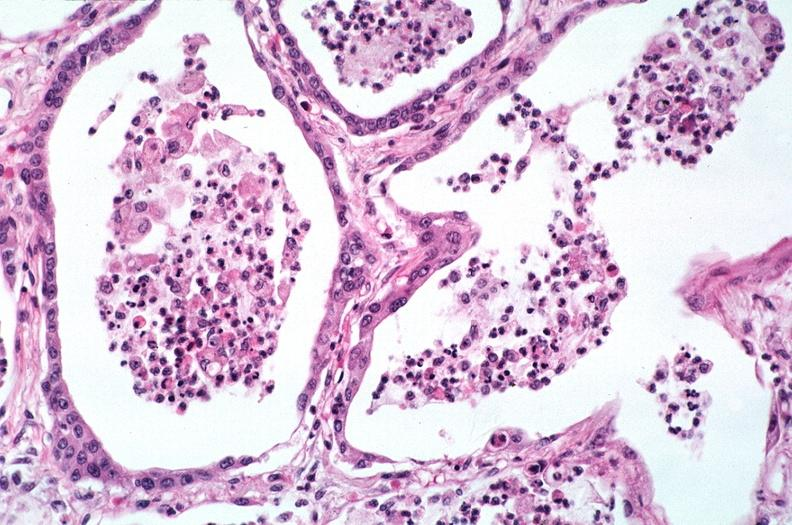where is this?
Answer the question using a single word or phrase. Lung 